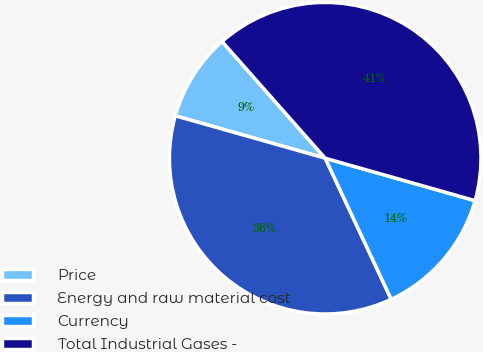Convert chart. <chart><loc_0><loc_0><loc_500><loc_500><pie_chart><fcel>Price<fcel>Energy and raw material cost<fcel>Currency<fcel>Total Industrial Gases -<nl><fcel>9.09%<fcel>36.36%<fcel>13.64%<fcel>40.91%<nl></chart> 